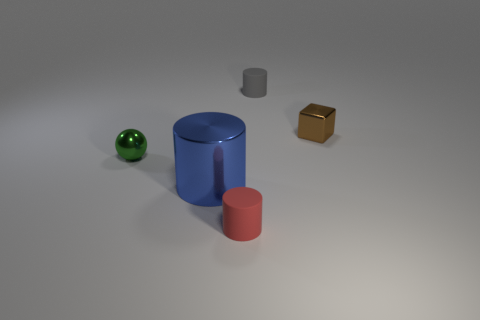Is there anything else that has the same material as the gray thing?
Keep it short and to the point. Yes. What material is the tiny brown block?
Keep it short and to the point. Metal. Is the material of the tiny brown cube the same as the red object?
Provide a succinct answer. No. How many matte things are either small green things or gray cylinders?
Provide a succinct answer. 1. What is the shape of the small shiny object right of the small green shiny ball?
Keep it short and to the point. Cube. What is the size of the ball that is made of the same material as the blue thing?
Offer a very short reply. Small. There is a shiny thing that is on the right side of the tiny green metallic object and behind the metallic cylinder; what shape is it?
Make the answer very short. Cube. Does the rubber cylinder that is behind the small green thing have the same color as the metal cylinder?
Give a very brief answer. No. Do the small rubber thing on the right side of the tiny red rubber cylinder and the blue metallic object that is behind the tiny red thing have the same shape?
Offer a terse response. Yes. What is the size of the shiny object that is in front of the small shiny ball?
Your answer should be very brief. Large. 